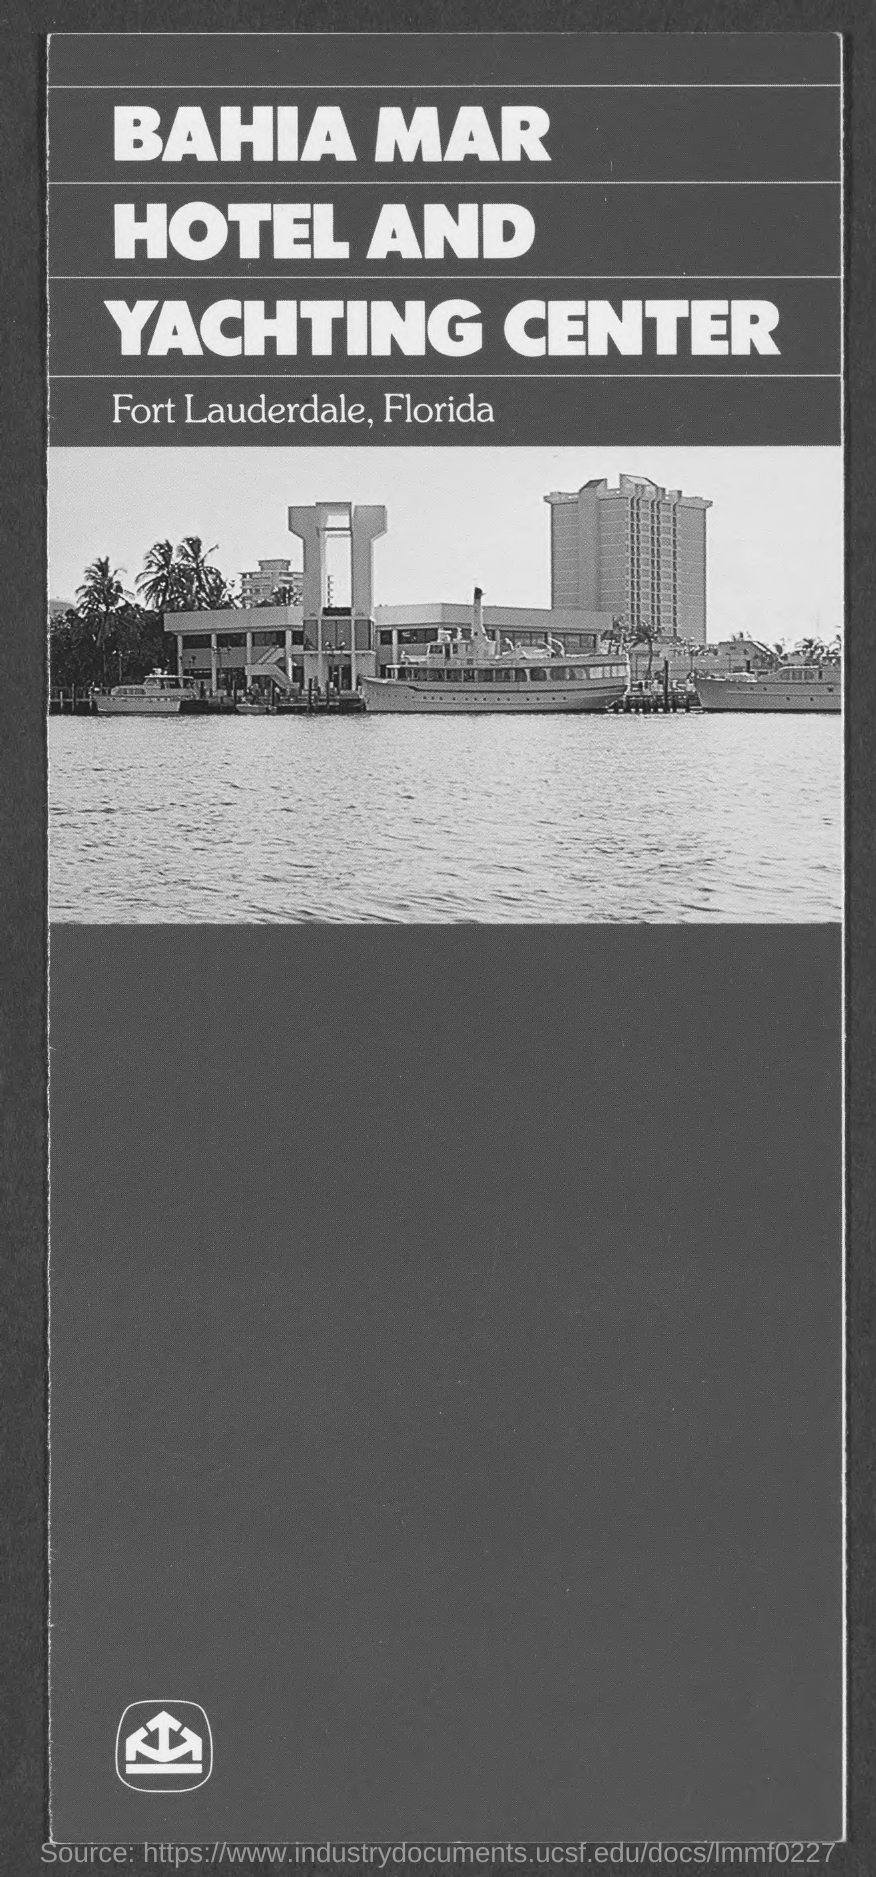Indicate a few pertinent items in this graphic. Bahia Mar Hotel and Yachting Center is located in the state of Florida. The location of BAHIA MAR HOTEL AND YACHTING CENTER is in Fort Lauderdale. The location of "BAHIA MAR HOTEL AND YACHTING CENTER" is Fort Lauderdale, Florida. The picture depicts the Bahia Mar Hotel and Yachting Center. 